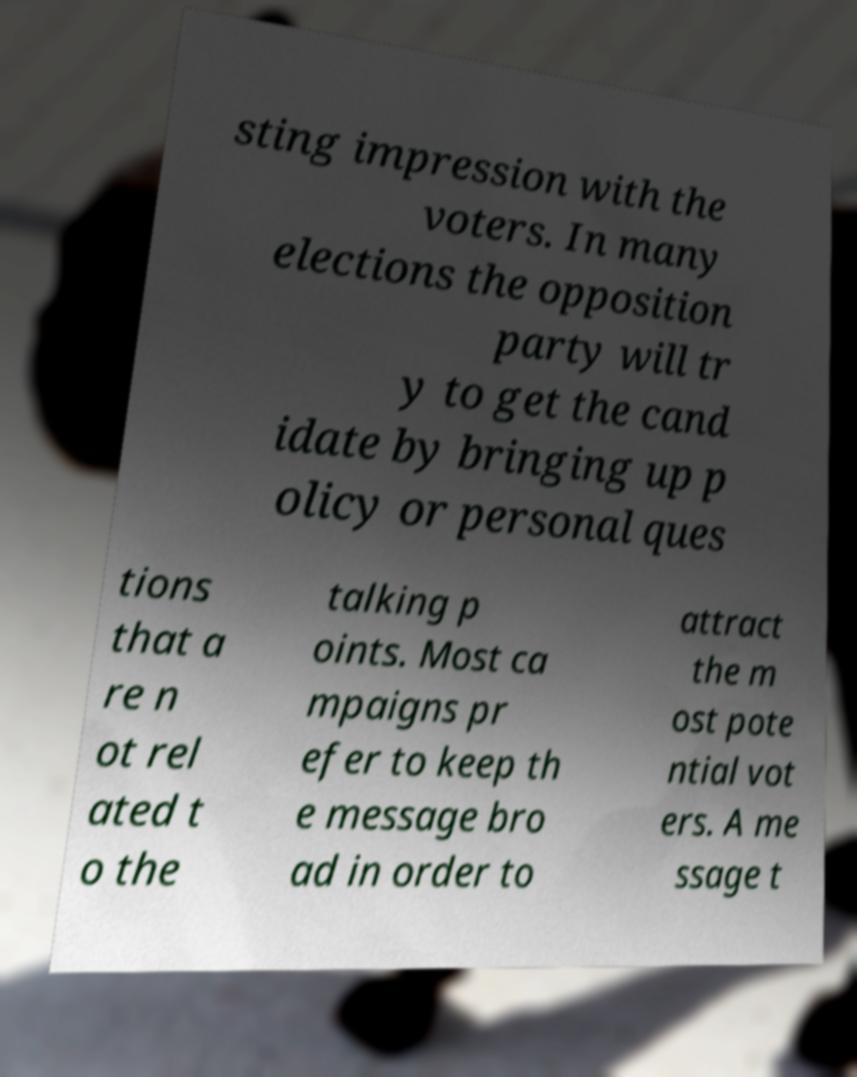Can you read and provide the text displayed in the image?This photo seems to have some interesting text. Can you extract and type it out for me? sting impression with the voters. In many elections the opposition party will tr y to get the cand idate by bringing up p olicy or personal ques tions that a re n ot rel ated t o the talking p oints. Most ca mpaigns pr efer to keep th e message bro ad in order to attract the m ost pote ntial vot ers. A me ssage t 